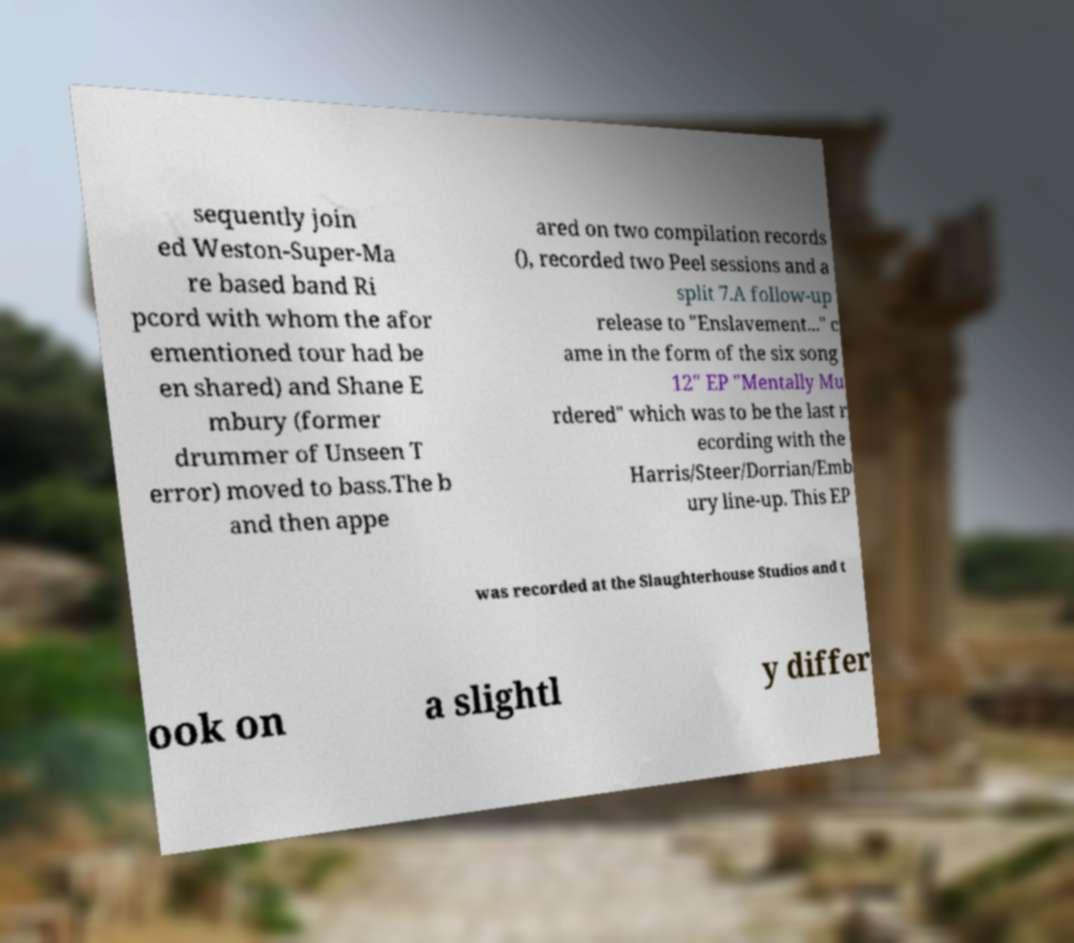I need the written content from this picture converted into text. Can you do that? sequently join ed Weston-Super-Ma re based band Ri pcord with whom the afor ementioned tour had be en shared) and Shane E mbury (former drummer of Unseen T error) moved to bass.The b and then appe ared on two compilation records (), recorded two Peel sessions and a split 7.A follow-up release to "Enslavement..." c ame in the form of the six song 12" EP "Mentally Mu rdered" which was to be the last r ecording with the Harris/Steer/Dorrian/Emb ury line-up. This EP was recorded at the Slaughterhouse Studios and t ook on a slightl y differ 